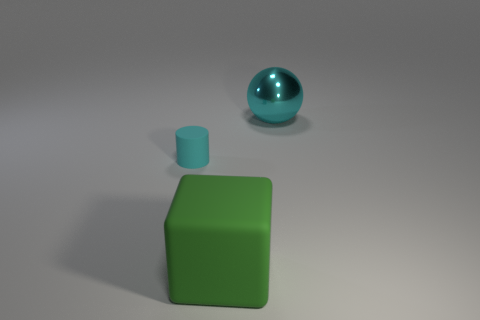Add 2 big metallic spheres. How many objects exist? 5 Subtract all cubes. How many objects are left? 2 Add 1 big blue metallic cylinders. How many big blue metallic cylinders exist? 1 Subtract 0 red cylinders. How many objects are left? 3 Subtract all spheres. Subtract all large cyan things. How many objects are left? 1 Add 3 cyan balls. How many cyan balls are left? 4 